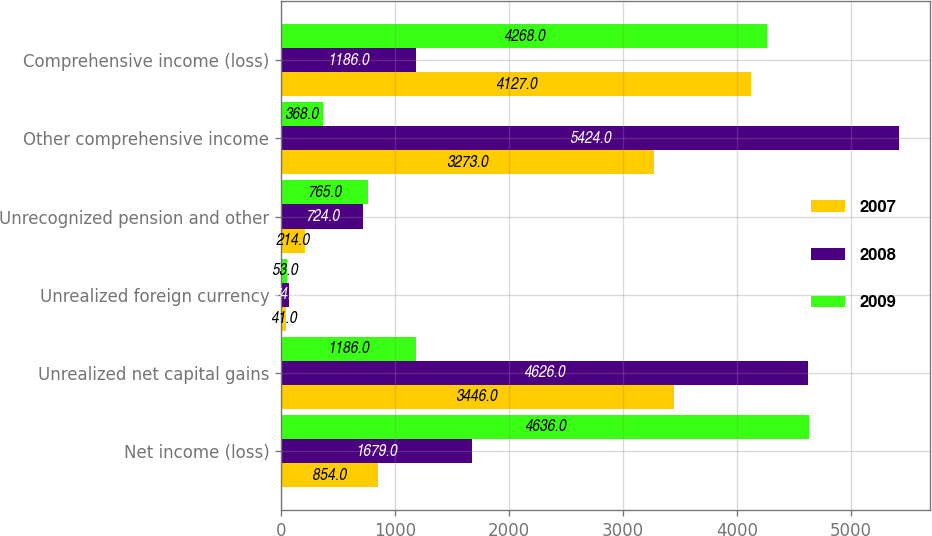Convert chart to OTSL. <chart><loc_0><loc_0><loc_500><loc_500><stacked_bar_chart><ecel><fcel>Net income (loss)<fcel>Unrealized net capital gains<fcel>Unrealized foreign currency<fcel>Unrecognized pension and other<fcel>Other comprehensive income<fcel>Comprehensive income (loss)<nl><fcel>2007<fcel>854<fcel>3446<fcel>41<fcel>214<fcel>3273<fcel>4127<nl><fcel>2008<fcel>1679<fcel>4626<fcel>74<fcel>724<fcel>5424<fcel>1186<nl><fcel>2009<fcel>4636<fcel>1186<fcel>53<fcel>765<fcel>368<fcel>4268<nl></chart> 